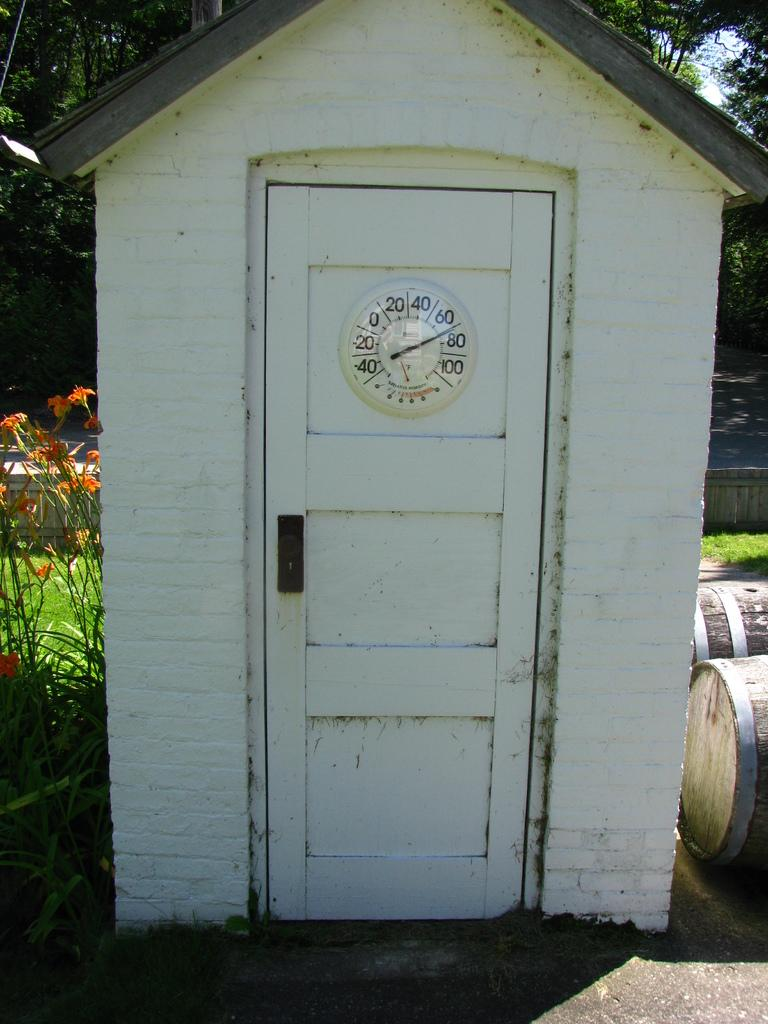<image>
Write a terse but informative summary of the picture. White shed with a clock that has the hands on the number 70. 